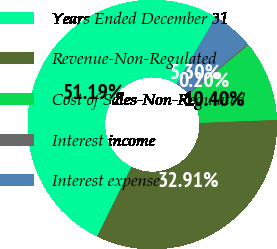Convert chart. <chart><loc_0><loc_0><loc_500><loc_500><pie_chart><fcel>Years Ended December 31<fcel>Revenue-Non-Regulated<fcel>Cost of Sales-Non-Regulated<fcel>Interest income<fcel>Interest expense<nl><fcel>51.18%<fcel>32.91%<fcel>10.4%<fcel>0.2%<fcel>5.3%<nl></chart> 